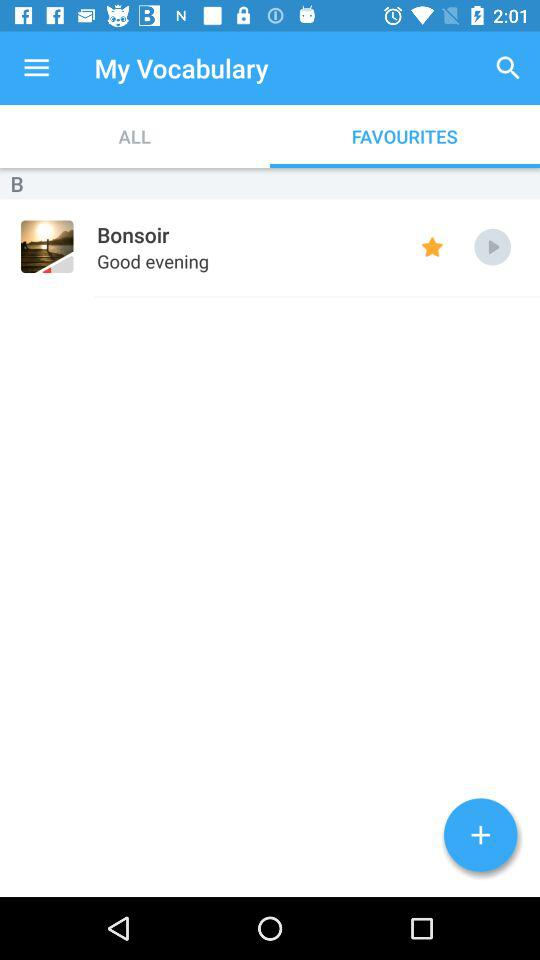Which tab is selected? The selected tab is "Favourites". 